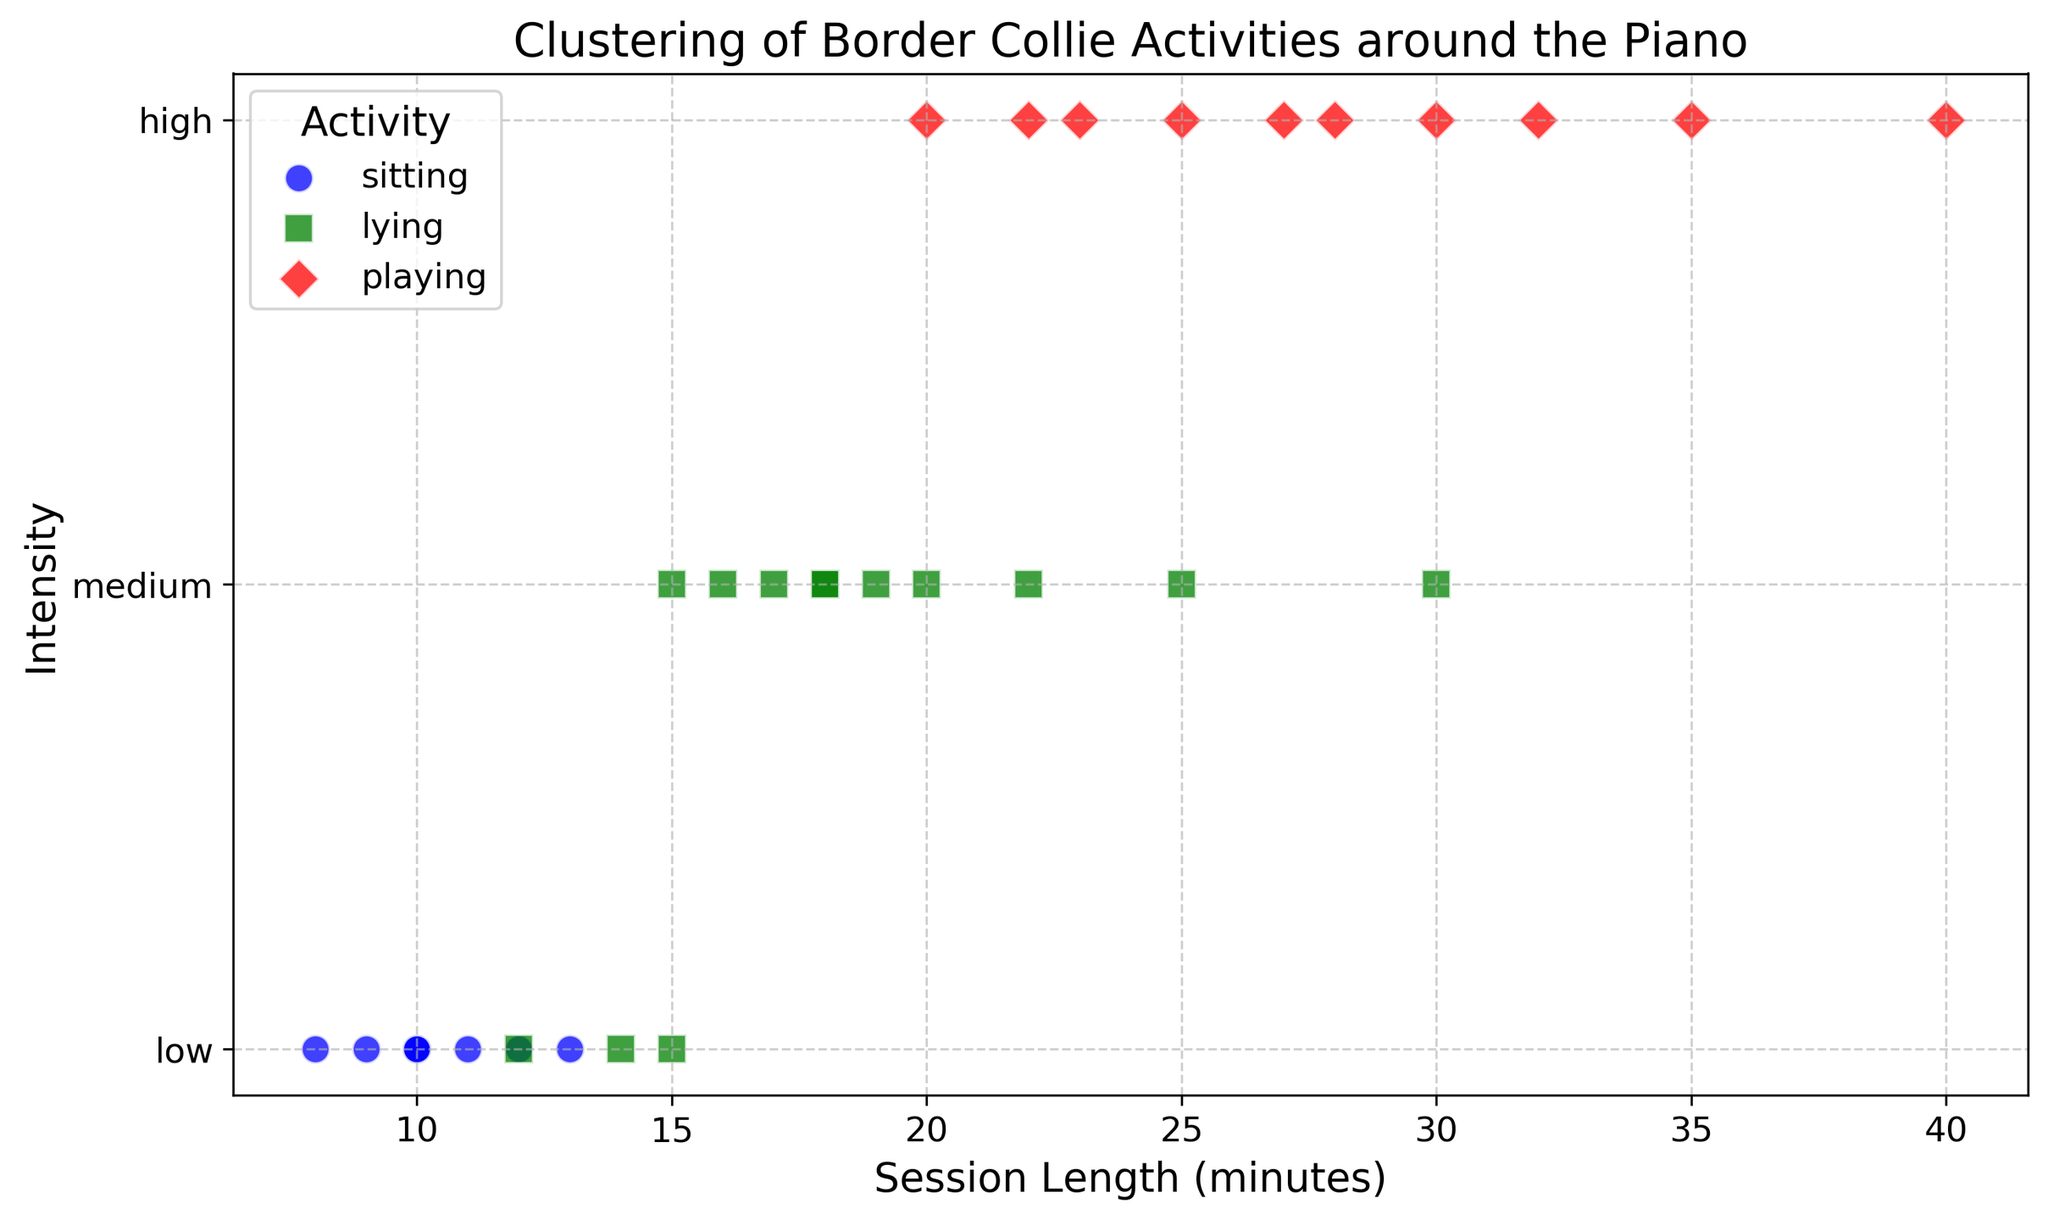What activity has the highest session length? The activity with the highest session length can be determined by identifying which activity has a data point at the far right of the x-axis. From the figure, the highest session length is around 40 minutes which corresponds to the 'playing' activity that is marked in red.
Answer: playing Which activity appears most frequently in low intensity sessions? To answer this, we need to observe the distribution of activities in the 'low' intensity category. Based on the number of blue (sitting) points in the low intensity section, sitting appears most frequently.
Answer: sitting How does the average session length of playing compare to lying? Calculate the average session length for playing and lying: Playing (25+30+20+35+40+22+32+23+27)/9 = 28.66 and Lying (15+20+18+25+17+22+15+12+18+30+16+19)=19.08. Compare the two averages.
Answer: The average session length is higher for playing Are there more medium intensity sessions of lying or high intensity sessions of playing? Count the number of medium intensity sessions for lying and high intensity sessions for playing. From the figure, medium intensity for lying has 9 data points, and high intensity for playing has 9 data points.
Answer: They are equal What color represents the sitting activity on the plot? Look at the legend in the figure; it shows that the blue color represents the sitting activity.
Answer: Blue What is the most common session length for sitting activity? Identify the session length that appears most frequently among the blue data points. The value 10 appears most frequently for sitting.
Answer: 10 Is there any overlap between sitting and playing activities in terms of session length? Examine the range of session lengths for sitting (blue) and playing (red). Session lengths for sitting are spread between 8 to 12, and for playing, they start from 20 onwards. Since there is no overlap between these ranges, there is no session length overlap between sitting and playing.
Answer: No What's the total number of low intensity sessions observed? Count all the data points in low intensity (blue and green markers at the bottom). There are 11 such points.
Answer: 11 Are there any activities clustered around a 20-minute session length? Check for any close grouping of points near the 20-minute mark on the x-axis. Both lying (green) and playing (red) have points near 20 minutes, suggesting clustering.
Answer: Lying and Playing What is the median session length for medium intensity lying activities? List the session lengths for medium intensity lying and sort them: 15, 16, 17, 18, 18, 19, 20, 22, 25. The middle value (5th in the sorted list since there's an odd number) is the median.
Answer: 18 